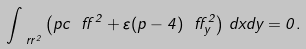Convert formula to latex. <formula><loc_0><loc_0><loc_500><loc_500>\int _ { \ r r ^ { 2 } } \left ( p c \ f f ^ { 2 } + \varepsilon ( p - 4 ) \ f f _ { y } ^ { 2 } \right ) \, d x d y = 0 .</formula> 